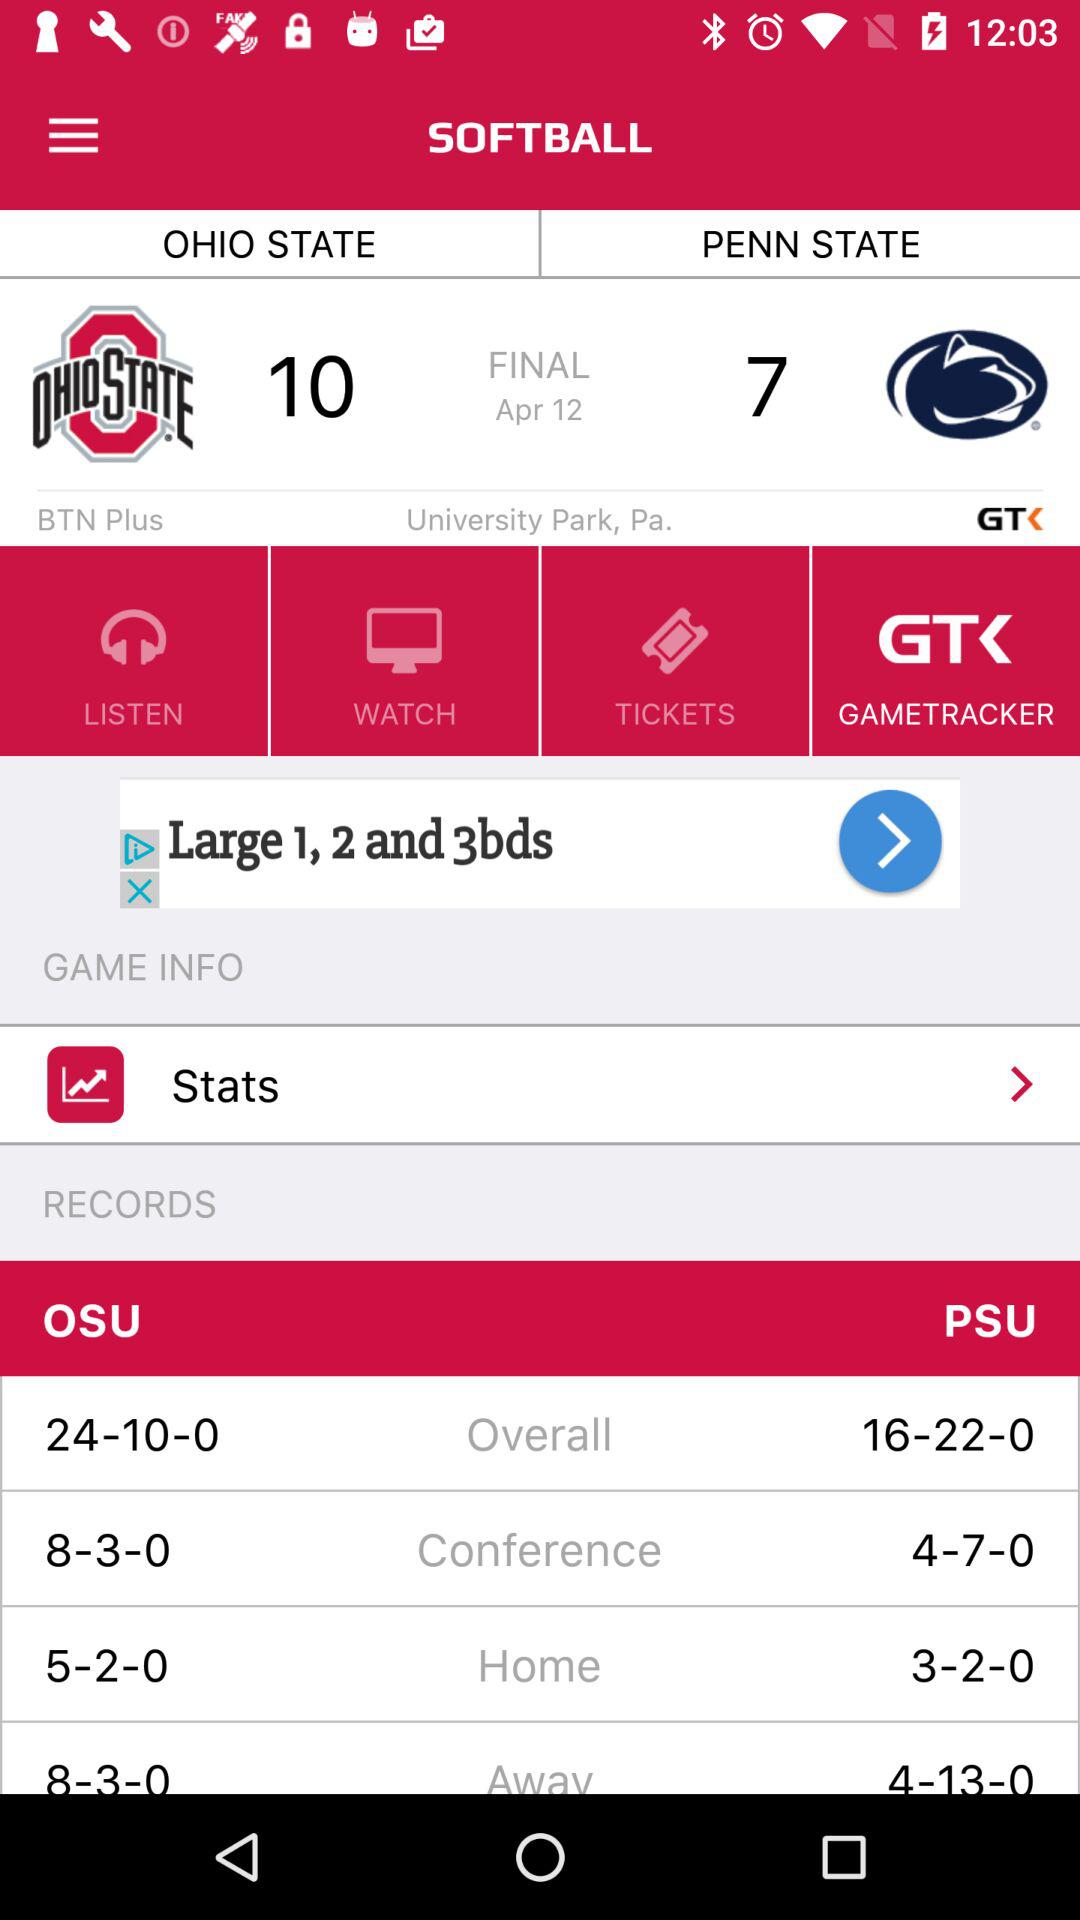What is the score of "PENN STATE" in final set? The score of "PENN STATE" in the final set is 7. 